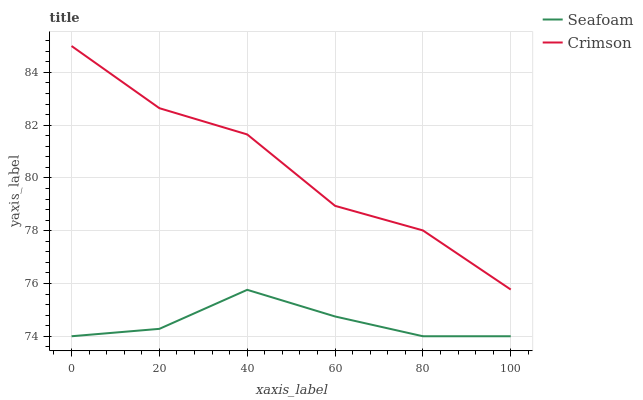Does Seafoam have the minimum area under the curve?
Answer yes or no. Yes. Does Crimson have the maximum area under the curve?
Answer yes or no. Yes. Does Seafoam have the maximum area under the curve?
Answer yes or no. No. Is Seafoam the smoothest?
Answer yes or no. Yes. Is Crimson the roughest?
Answer yes or no. Yes. Is Seafoam the roughest?
Answer yes or no. No. Does Crimson have the highest value?
Answer yes or no. Yes. Does Seafoam have the highest value?
Answer yes or no. No. Is Seafoam less than Crimson?
Answer yes or no. Yes. Is Crimson greater than Seafoam?
Answer yes or no. Yes. Does Seafoam intersect Crimson?
Answer yes or no. No. 